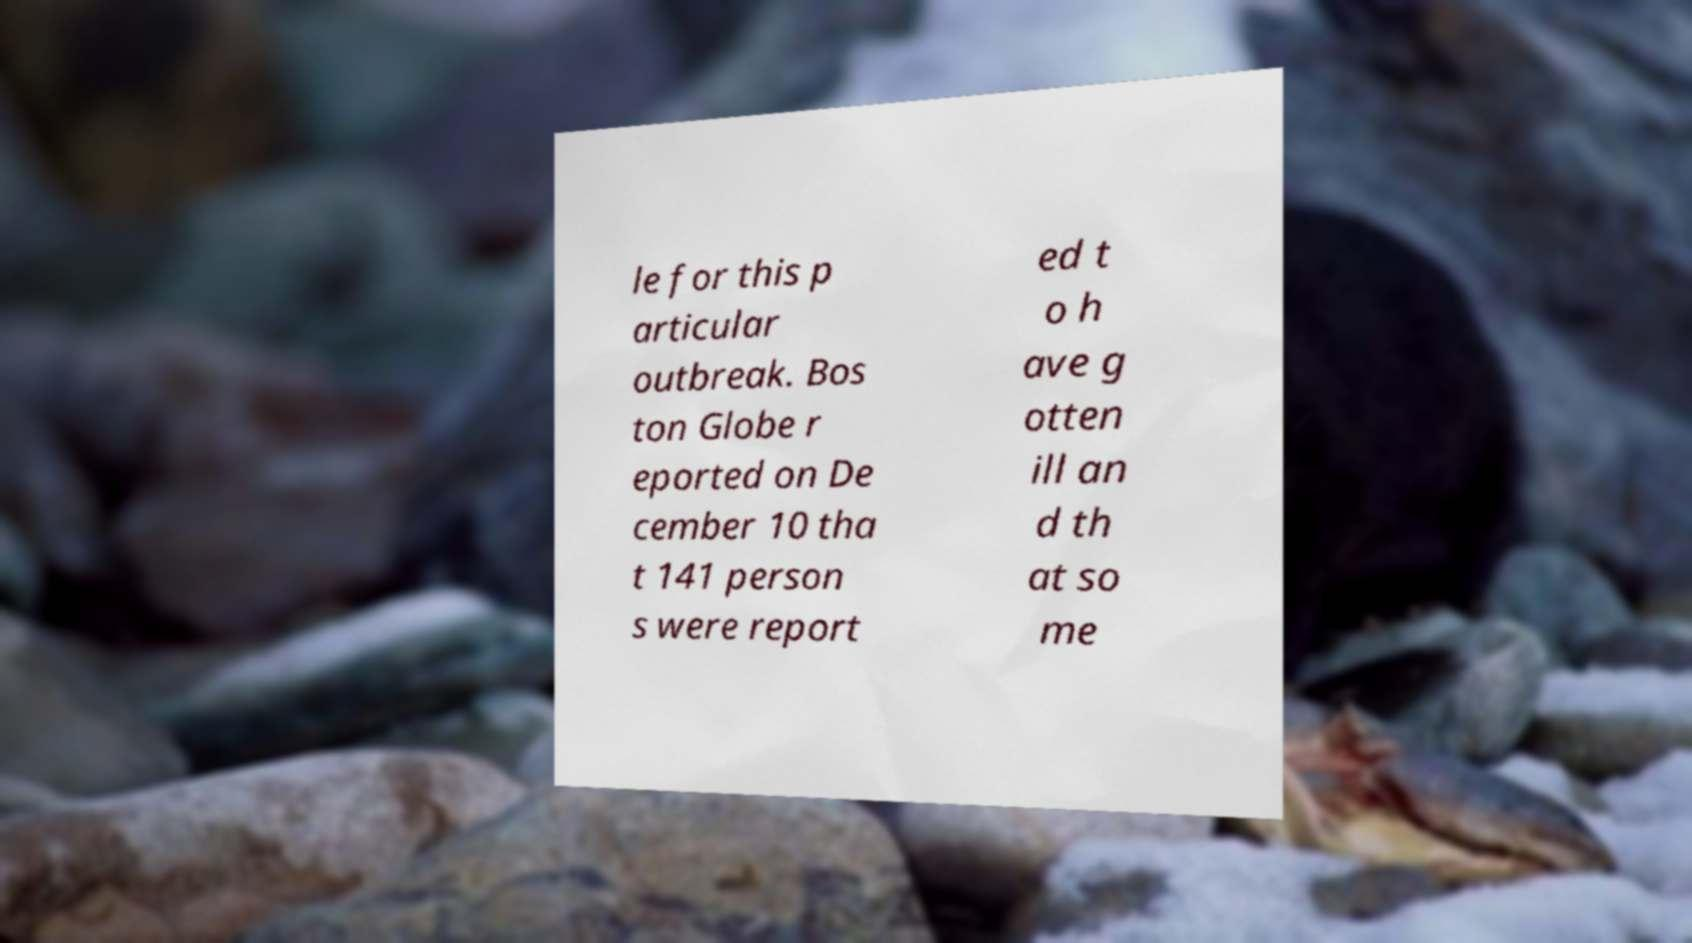There's text embedded in this image that I need extracted. Can you transcribe it verbatim? le for this p articular outbreak. Bos ton Globe r eported on De cember 10 tha t 141 person s were report ed t o h ave g otten ill an d th at so me 